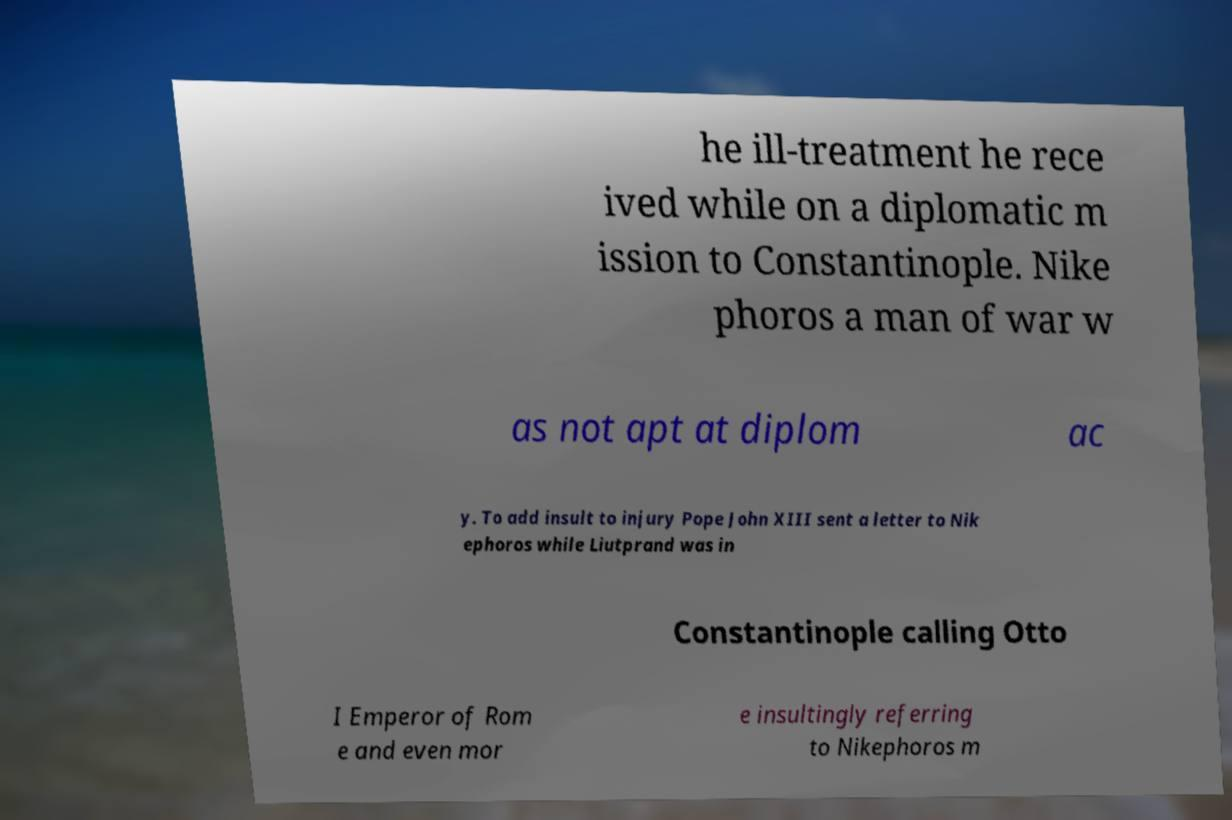Please read and relay the text visible in this image. What does it say? he ill-treatment he rece ived while on a diplomatic m ission to Constantinople. Nike phoros a man of war w as not apt at diplom ac y. To add insult to injury Pope John XIII sent a letter to Nik ephoros while Liutprand was in Constantinople calling Otto I Emperor of Rom e and even mor e insultingly referring to Nikephoros m 